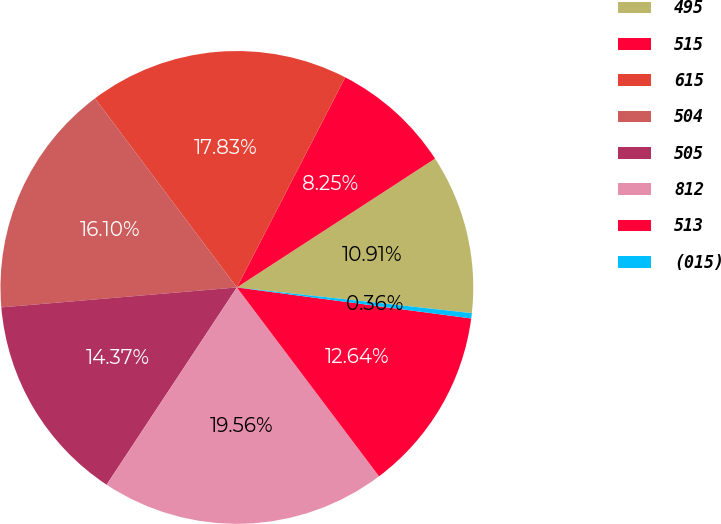<chart> <loc_0><loc_0><loc_500><loc_500><pie_chart><fcel>495<fcel>515<fcel>615<fcel>504<fcel>505<fcel>812<fcel>513<fcel>(015)<nl><fcel>10.91%<fcel>8.25%<fcel>17.83%<fcel>16.1%<fcel>14.37%<fcel>19.56%<fcel>12.64%<fcel>0.36%<nl></chart> 